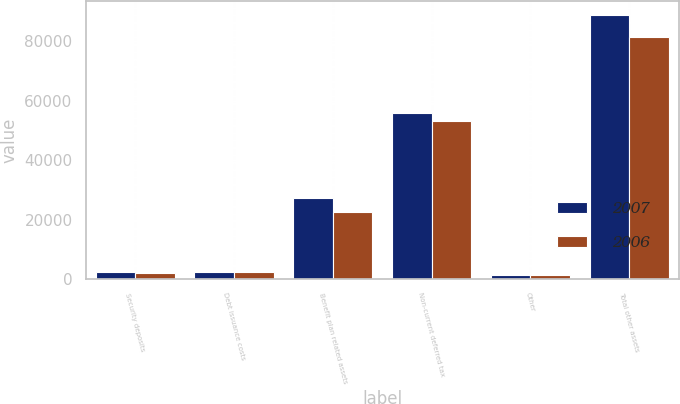<chart> <loc_0><loc_0><loc_500><loc_500><stacked_bar_chart><ecel><fcel>Security deposits<fcel>Debt issuance costs<fcel>Benefit plan related assets<fcel>Non-current deferred tax<fcel>Other<fcel>Total other assets<nl><fcel>2007<fcel>2328<fcel>2441<fcel>27248<fcel>55845<fcel>1181<fcel>89043<nl><fcel>2006<fcel>1903<fcel>2313<fcel>22657<fcel>53319<fcel>1330<fcel>81522<nl></chart> 